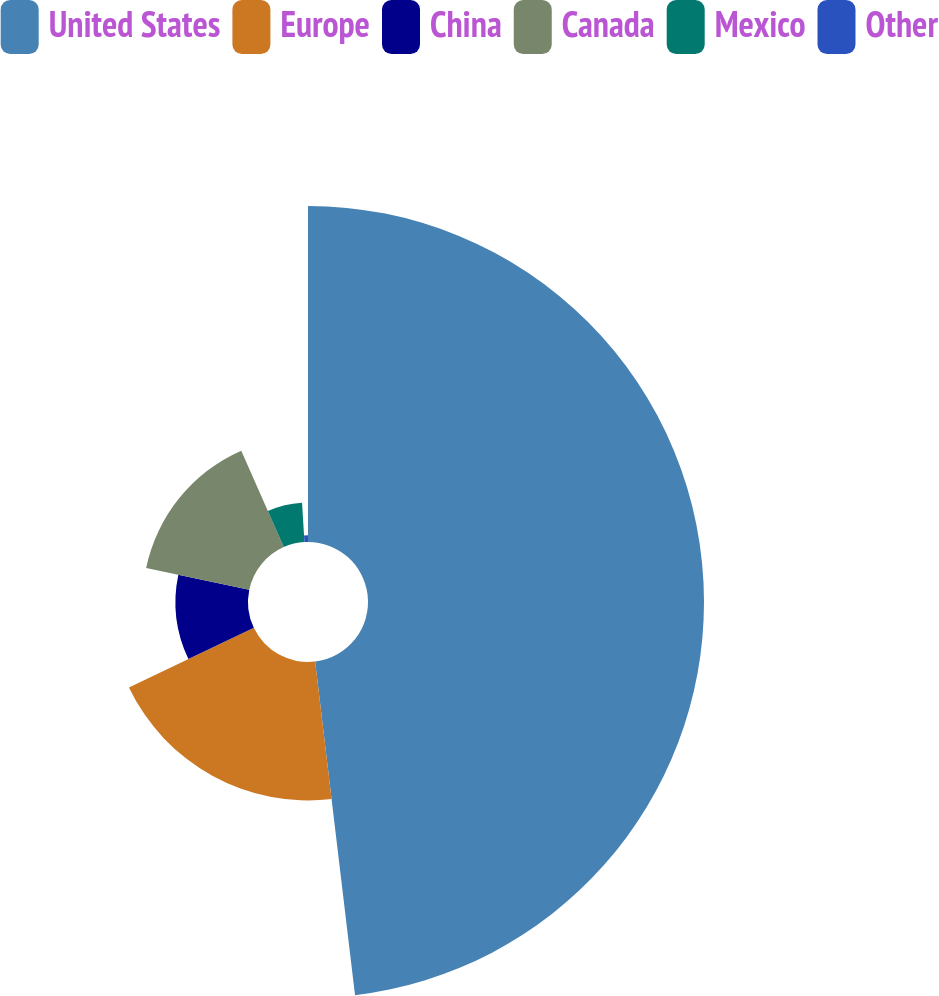Convert chart to OTSL. <chart><loc_0><loc_0><loc_500><loc_500><pie_chart><fcel>United States<fcel>Europe<fcel>China<fcel>Canada<fcel>Mexico<fcel>Other<nl><fcel>48.1%<fcel>19.81%<fcel>10.38%<fcel>15.09%<fcel>5.66%<fcel>0.95%<nl></chart> 